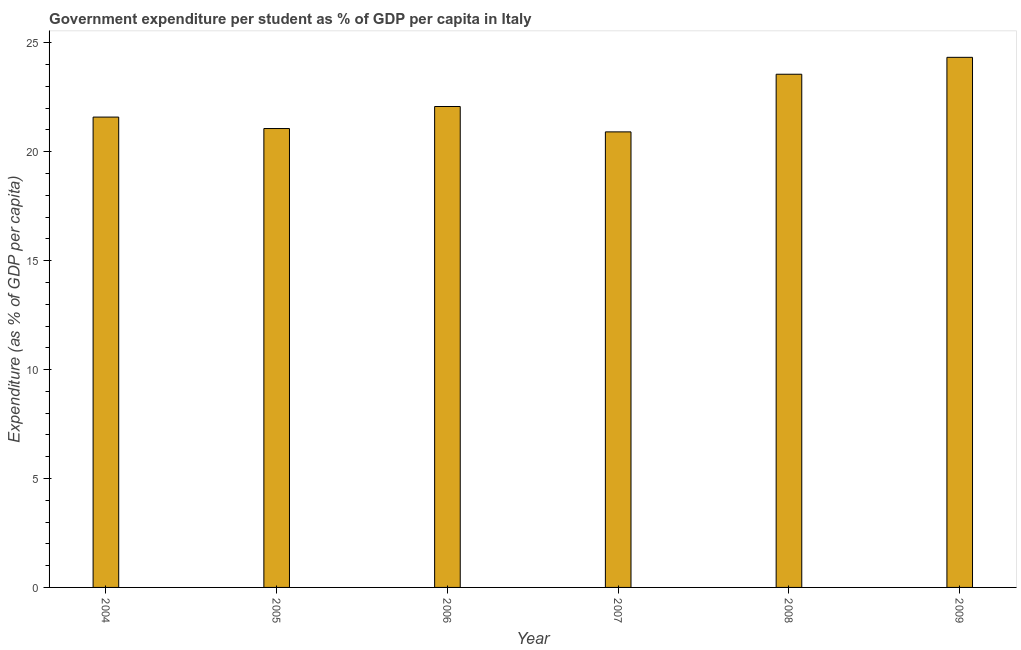Does the graph contain any zero values?
Your response must be concise. No. Does the graph contain grids?
Provide a short and direct response. No. What is the title of the graph?
Keep it short and to the point. Government expenditure per student as % of GDP per capita in Italy. What is the label or title of the X-axis?
Provide a succinct answer. Year. What is the label or title of the Y-axis?
Provide a succinct answer. Expenditure (as % of GDP per capita). What is the government expenditure per student in 2006?
Keep it short and to the point. 22.08. Across all years, what is the maximum government expenditure per student?
Offer a very short reply. 24.33. Across all years, what is the minimum government expenditure per student?
Provide a succinct answer. 20.91. What is the sum of the government expenditure per student?
Give a very brief answer. 133.54. What is the difference between the government expenditure per student in 2004 and 2009?
Offer a terse response. -2.74. What is the average government expenditure per student per year?
Your answer should be very brief. 22.26. What is the median government expenditure per student?
Offer a terse response. 21.83. In how many years, is the government expenditure per student greater than 9 %?
Provide a short and direct response. 6. Do a majority of the years between 2006 and 2007 (inclusive) have government expenditure per student greater than 10 %?
Provide a succinct answer. Yes. Is the government expenditure per student in 2004 less than that in 2006?
Provide a succinct answer. Yes. Is the difference between the government expenditure per student in 2006 and 2007 greater than the difference between any two years?
Provide a short and direct response. No. What is the difference between the highest and the second highest government expenditure per student?
Provide a succinct answer. 0.78. What is the difference between the highest and the lowest government expenditure per student?
Offer a very short reply. 3.42. In how many years, is the government expenditure per student greater than the average government expenditure per student taken over all years?
Keep it short and to the point. 2. How many years are there in the graph?
Offer a terse response. 6. What is the Expenditure (as % of GDP per capita) in 2004?
Offer a terse response. 21.59. What is the Expenditure (as % of GDP per capita) of 2005?
Offer a terse response. 21.07. What is the Expenditure (as % of GDP per capita) of 2006?
Your answer should be very brief. 22.08. What is the Expenditure (as % of GDP per capita) of 2007?
Offer a very short reply. 20.91. What is the Expenditure (as % of GDP per capita) in 2008?
Keep it short and to the point. 23.56. What is the Expenditure (as % of GDP per capita) of 2009?
Your answer should be very brief. 24.33. What is the difference between the Expenditure (as % of GDP per capita) in 2004 and 2005?
Keep it short and to the point. 0.53. What is the difference between the Expenditure (as % of GDP per capita) in 2004 and 2006?
Offer a terse response. -0.49. What is the difference between the Expenditure (as % of GDP per capita) in 2004 and 2007?
Give a very brief answer. 0.68. What is the difference between the Expenditure (as % of GDP per capita) in 2004 and 2008?
Your answer should be compact. -1.97. What is the difference between the Expenditure (as % of GDP per capita) in 2004 and 2009?
Offer a very short reply. -2.74. What is the difference between the Expenditure (as % of GDP per capita) in 2005 and 2006?
Ensure brevity in your answer.  -1.01. What is the difference between the Expenditure (as % of GDP per capita) in 2005 and 2007?
Provide a succinct answer. 0.15. What is the difference between the Expenditure (as % of GDP per capita) in 2005 and 2008?
Ensure brevity in your answer.  -2.49. What is the difference between the Expenditure (as % of GDP per capita) in 2005 and 2009?
Give a very brief answer. -3.27. What is the difference between the Expenditure (as % of GDP per capita) in 2006 and 2007?
Offer a very short reply. 1.16. What is the difference between the Expenditure (as % of GDP per capita) in 2006 and 2008?
Your response must be concise. -1.48. What is the difference between the Expenditure (as % of GDP per capita) in 2006 and 2009?
Offer a terse response. -2.26. What is the difference between the Expenditure (as % of GDP per capita) in 2007 and 2008?
Provide a short and direct response. -2.65. What is the difference between the Expenditure (as % of GDP per capita) in 2007 and 2009?
Provide a short and direct response. -3.42. What is the difference between the Expenditure (as % of GDP per capita) in 2008 and 2009?
Provide a succinct answer. -0.78. What is the ratio of the Expenditure (as % of GDP per capita) in 2004 to that in 2007?
Offer a terse response. 1.03. What is the ratio of the Expenditure (as % of GDP per capita) in 2004 to that in 2008?
Ensure brevity in your answer.  0.92. What is the ratio of the Expenditure (as % of GDP per capita) in 2004 to that in 2009?
Ensure brevity in your answer.  0.89. What is the ratio of the Expenditure (as % of GDP per capita) in 2005 to that in 2006?
Keep it short and to the point. 0.95. What is the ratio of the Expenditure (as % of GDP per capita) in 2005 to that in 2008?
Your answer should be compact. 0.89. What is the ratio of the Expenditure (as % of GDP per capita) in 2005 to that in 2009?
Your answer should be compact. 0.87. What is the ratio of the Expenditure (as % of GDP per capita) in 2006 to that in 2007?
Your answer should be compact. 1.06. What is the ratio of the Expenditure (as % of GDP per capita) in 2006 to that in 2008?
Offer a terse response. 0.94. What is the ratio of the Expenditure (as % of GDP per capita) in 2006 to that in 2009?
Your answer should be very brief. 0.91. What is the ratio of the Expenditure (as % of GDP per capita) in 2007 to that in 2008?
Ensure brevity in your answer.  0.89. What is the ratio of the Expenditure (as % of GDP per capita) in 2007 to that in 2009?
Make the answer very short. 0.86. What is the ratio of the Expenditure (as % of GDP per capita) in 2008 to that in 2009?
Your answer should be compact. 0.97. 